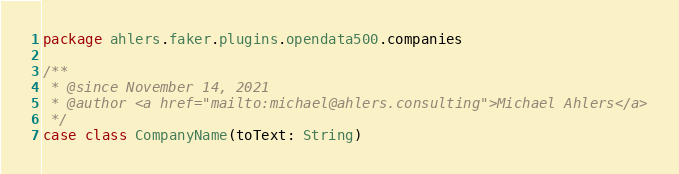<code> <loc_0><loc_0><loc_500><loc_500><_Scala_>package ahlers.faker.plugins.opendata500.companies

/**
 * @since November 14, 2021
 * @author <a href="mailto:michael@ahlers.consulting">Michael Ahlers</a>
 */
case class CompanyName(toText: String)
</code> 